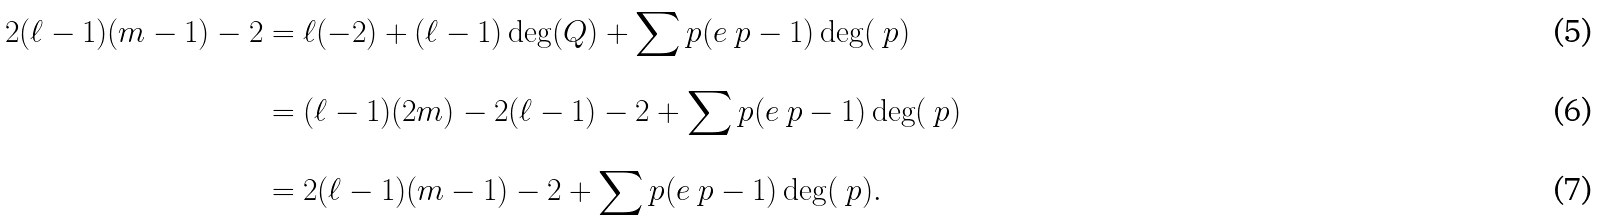Convert formula to latex. <formula><loc_0><loc_0><loc_500><loc_500>2 ( \ell - 1 ) ( m - 1 ) - 2 & = \ell ( - 2 ) + ( \ell - 1 ) \deg ( Q ) + \sum _ { \ } p ( e _ { \ } p - 1 ) \deg ( \ p ) \\ & = ( \ell - 1 ) ( 2 m ) - 2 ( \ell - 1 ) - 2 + \sum _ { \ } p ( e _ { \ } p - 1 ) \deg ( \ p ) \\ & = 2 ( \ell - 1 ) ( m - 1 ) - 2 + \sum _ { \ } p ( e _ { \ } p - 1 ) \deg ( \ p ) .</formula> 